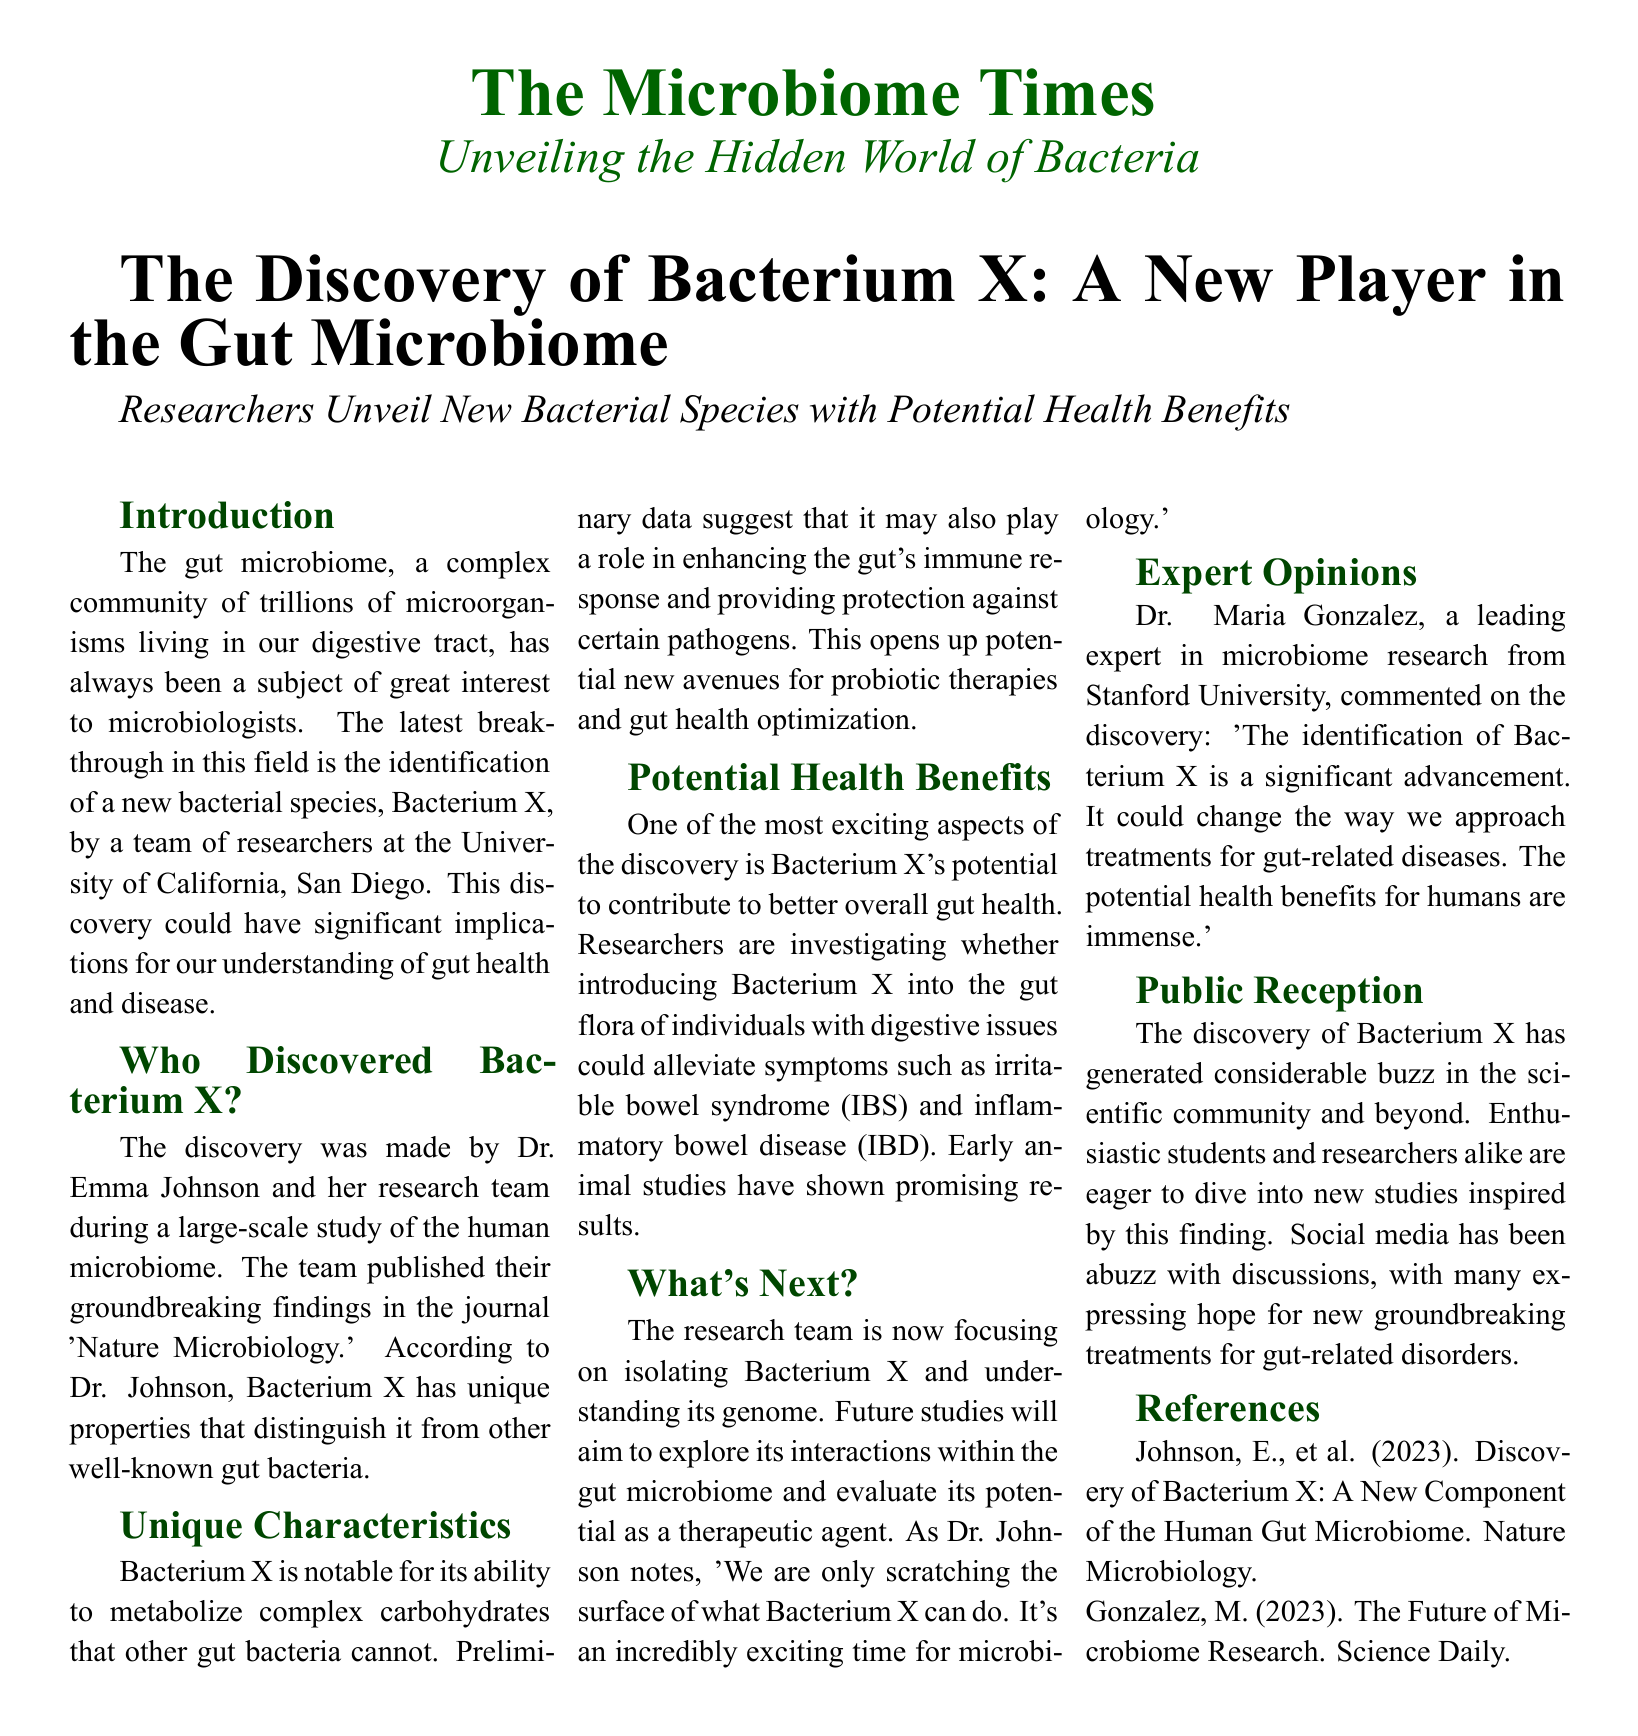What is the name of the newly discovered bacterium? The newly discovered bacterium is referred to as Bacterium X.
Answer: Bacterium X Who led the research team that discovered Bacterium X? The research team that discovered Bacterium X was led by Dr. Emma Johnson.
Answer: Dr. Emma Johnson In which journal were the findings about Bacterium X published? The findings about Bacterium X were published in the journal 'Nature Microbiology.'
Answer: Nature Microbiology What unique ability does Bacterium X possess? Bacterium X has the ability to metabolize complex carbohydrates that other gut bacteria cannot.
Answer: Metabolize complex carbohydrates What potential health issue might Bacterium X help alleviate? Bacterium X might help alleviate symptoms of irritable bowel syndrome (IBS) and inflammatory bowel disease (IBD).
Answer: IBS and IBD What is the next focus of the research team regarding Bacterium X? The next focus of the research team is isolating Bacterium X and understanding its genome.
Answer: Isolating Bacterium X and understanding its genome What characterized the public's reaction to the discovery of Bacterium X? The discovery of Bacterium X has generated considerable buzz in the scientific community and beyond.
Answer: Considerable buzz Which expert commented on the significance of discovering Bacterium X? Dr. Maria Gonzalez commented on the significance of discovering Bacterium X.
Answer: Dr. Maria Gonzalez 